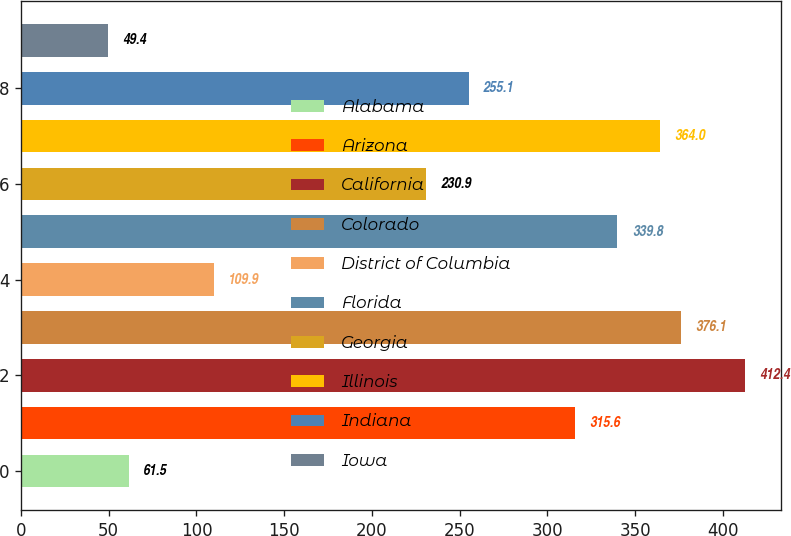Convert chart to OTSL. <chart><loc_0><loc_0><loc_500><loc_500><bar_chart><fcel>Alabama<fcel>Arizona<fcel>California<fcel>Colorado<fcel>District of Columbia<fcel>Florida<fcel>Georgia<fcel>Illinois<fcel>Indiana<fcel>Iowa<nl><fcel>61.5<fcel>315.6<fcel>412.4<fcel>376.1<fcel>109.9<fcel>339.8<fcel>230.9<fcel>364<fcel>255.1<fcel>49.4<nl></chart> 